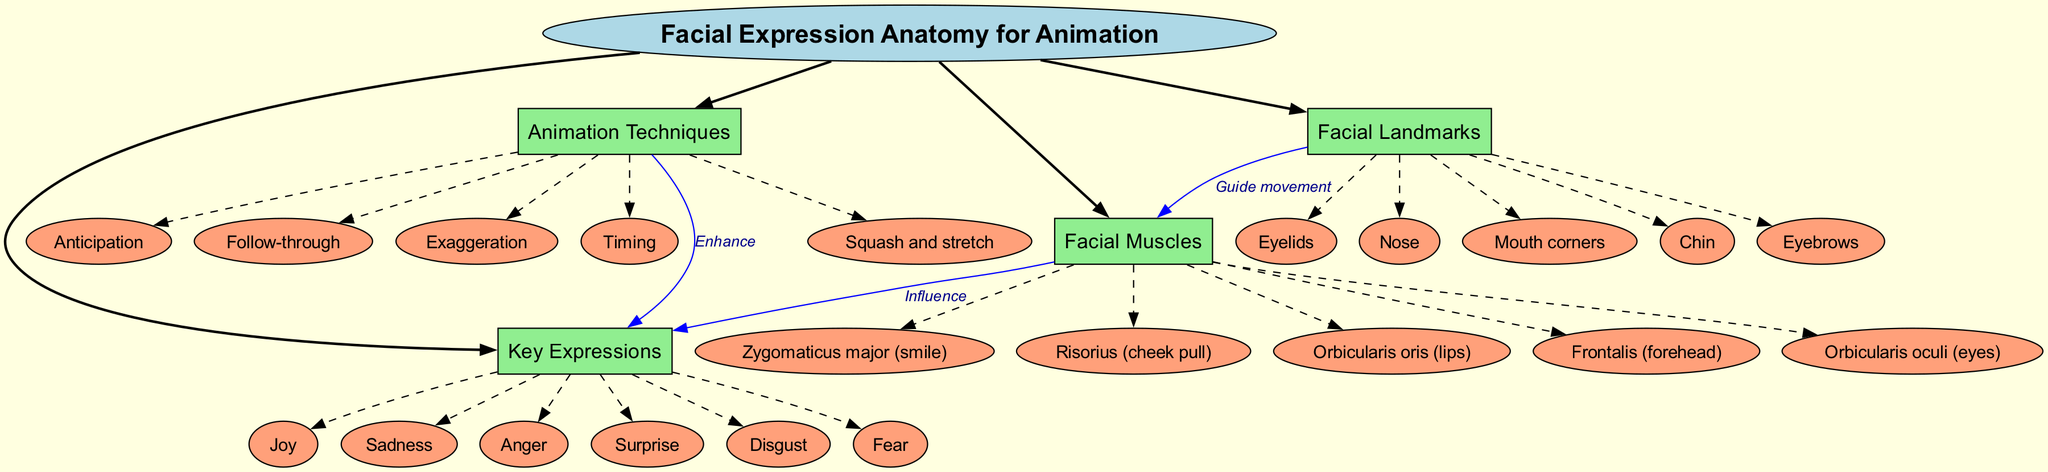What are the five key expressions listed in the diagram? The diagram specifically names six key expressions under the "Key Expressions" branch: Joy, Sadness, Anger, Surprise, Disgust, and Fear.
Answer: Joy, Sadness, Anger, Surprise, Disgust, Fear How many main branches are present in the diagram? The diagram includes four main branches: Facial Muscles, Key Expressions, Animation Techniques, and Facial Landmarks. Therefore, the total count of main branches is four.
Answer: four Which facial muscle is responsible for a smile? The muscle associated with a smile is the Zygomaticus major, as indicated in the "Facial Muscles" branch under sub-branches.
Answer: Zygomaticus major What is the relationship between Facial Muscles and Key Expressions? The diagram indicates that Facial Muscles influence Key Expressions. When exploring the connection, we see a directed edge labeled "Influence" pointing from Facial Muscles to Key Expressions.
Answer: Influence How many sub-branches does the Animation Techniques branch have? The Animation Techniques branch contains five sub-branches: Squash and stretch, Anticipation, Follow-through, Exaggeration, and Timing, which totals five sub-branches.
Answer: five What do Facial Landmarks do in relation to Facial Muscles? The connection shows that Facial Landmarks guide movement for Facial Muscles, which is explicitly stated in the diagram with a directed edge labeled "Guide movement."
Answer: Guide movement Which expression corresponds to the feeling of being startled? The expression that corresponds to the feeling of being startled is Surprise, which appears in the list of Key Expressions.
Answer: Surprise What are the three facial landmarks mentioned in the diagram? The diagram lists five facial landmarks: Eyebrows, Eyelids, Nose, Mouth corners, and Chin; thus, any three landmarks from this list are valid. For example, Eyebrows, Nose, and Chin.
Answer: Eyebrows, Nose, Chin What is the technique used in animation to create realistic motion? One key technique identified in the "Animation Techniques" branch is Timing, known for helping in achieving realistic motion during animation.
Answer: Timing 